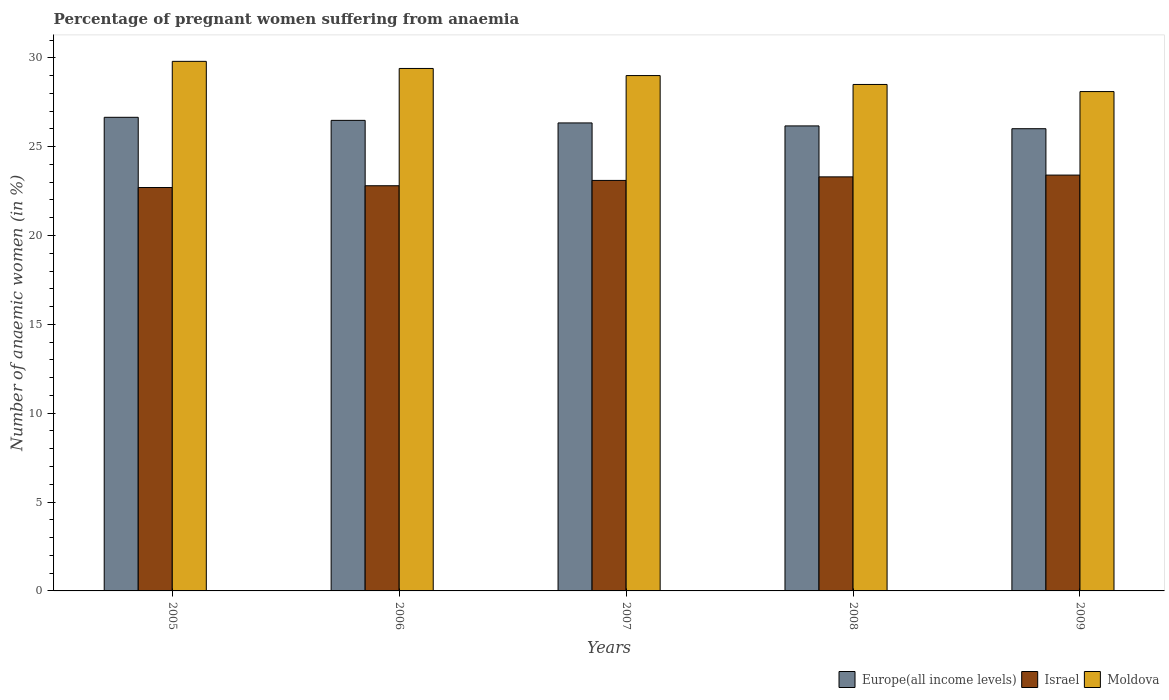How many different coloured bars are there?
Offer a very short reply. 3. How many groups of bars are there?
Offer a very short reply. 5. Are the number of bars per tick equal to the number of legend labels?
Offer a very short reply. Yes. Are the number of bars on each tick of the X-axis equal?
Ensure brevity in your answer.  Yes. How many bars are there on the 2nd tick from the left?
Your answer should be very brief. 3. In how many cases, is the number of bars for a given year not equal to the number of legend labels?
Your answer should be compact. 0. What is the number of anaemic women in Europe(all income levels) in 2007?
Provide a short and direct response. 26.34. Across all years, what is the maximum number of anaemic women in Europe(all income levels)?
Your answer should be compact. 26.65. Across all years, what is the minimum number of anaemic women in Europe(all income levels)?
Give a very brief answer. 26.01. What is the total number of anaemic women in Israel in the graph?
Give a very brief answer. 115.3. What is the difference between the number of anaemic women in Europe(all income levels) in 2008 and that in 2009?
Ensure brevity in your answer.  0.16. What is the difference between the number of anaemic women in Moldova in 2007 and the number of anaemic women in Israel in 2006?
Your answer should be compact. 6.2. What is the average number of anaemic women in Israel per year?
Your answer should be very brief. 23.06. In the year 2007, what is the difference between the number of anaemic women in Europe(all income levels) and number of anaemic women in Israel?
Your answer should be compact. 3.24. What is the ratio of the number of anaemic women in Europe(all income levels) in 2006 to that in 2007?
Your answer should be very brief. 1.01. What is the difference between the highest and the second highest number of anaemic women in Israel?
Your answer should be very brief. 0.1. What is the difference between the highest and the lowest number of anaemic women in Moldova?
Offer a terse response. 1.7. What does the 2nd bar from the right in 2009 represents?
Your answer should be compact. Israel. Is it the case that in every year, the sum of the number of anaemic women in Moldova and number of anaemic women in Europe(all income levels) is greater than the number of anaemic women in Israel?
Give a very brief answer. Yes. Are all the bars in the graph horizontal?
Give a very brief answer. No. What is the difference between two consecutive major ticks on the Y-axis?
Make the answer very short. 5. Does the graph contain grids?
Your response must be concise. No. Where does the legend appear in the graph?
Make the answer very short. Bottom right. What is the title of the graph?
Make the answer very short. Percentage of pregnant women suffering from anaemia. What is the label or title of the Y-axis?
Offer a very short reply. Number of anaemic women (in %). What is the Number of anaemic women (in %) in Europe(all income levels) in 2005?
Your answer should be compact. 26.65. What is the Number of anaemic women (in %) of Israel in 2005?
Provide a succinct answer. 22.7. What is the Number of anaemic women (in %) in Moldova in 2005?
Provide a short and direct response. 29.8. What is the Number of anaemic women (in %) in Europe(all income levels) in 2006?
Make the answer very short. 26.48. What is the Number of anaemic women (in %) of Israel in 2006?
Keep it short and to the point. 22.8. What is the Number of anaemic women (in %) of Moldova in 2006?
Make the answer very short. 29.4. What is the Number of anaemic women (in %) in Europe(all income levels) in 2007?
Your answer should be compact. 26.34. What is the Number of anaemic women (in %) in Israel in 2007?
Your answer should be very brief. 23.1. What is the Number of anaemic women (in %) in Europe(all income levels) in 2008?
Offer a terse response. 26.17. What is the Number of anaemic women (in %) in Israel in 2008?
Keep it short and to the point. 23.3. What is the Number of anaemic women (in %) of Moldova in 2008?
Offer a very short reply. 28.5. What is the Number of anaemic women (in %) in Europe(all income levels) in 2009?
Your response must be concise. 26.01. What is the Number of anaemic women (in %) in Israel in 2009?
Your answer should be very brief. 23.4. What is the Number of anaemic women (in %) in Moldova in 2009?
Your answer should be compact. 28.1. Across all years, what is the maximum Number of anaemic women (in %) in Europe(all income levels)?
Provide a succinct answer. 26.65. Across all years, what is the maximum Number of anaemic women (in %) in Israel?
Offer a very short reply. 23.4. Across all years, what is the maximum Number of anaemic women (in %) of Moldova?
Keep it short and to the point. 29.8. Across all years, what is the minimum Number of anaemic women (in %) of Europe(all income levels)?
Your answer should be compact. 26.01. Across all years, what is the minimum Number of anaemic women (in %) in Israel?
Your answer should be compact. 22.7. Across all years, what is the minimum Number of anaemic women (in %) of Moldova?
Your answer should be compact. 28.1. What is the total Number of anaemic women (in %) in Europe(all income levels) in the graph?
Your answer should be compact. 131.64. What is the total Number of anaemic women (in %) in Israel in the graph?
Your answer should be compact. 115.3. What is the total Number of anaemic women (in %) of Moldova in the graph?
Provide a short and direct response. 144.8. What is the difference between the Number of anaemic women (in %) in Europe(all income levels) in 2005 and that in 2006?
Provide a succinct answer. 0.17. What is the difference between the Number of anaemic women (in %) in Israel in 2005 and that in 2006?
Your answer should be compact. -0.1. What is the difference between the Number of anaemic women (in %) in Europe(all income levels) in 2005 and that in 2007?
Ensure brevity in your answer.  0.32. What is the difference between the Number of anaemic women (in %) in Moldova in 2005 and that in 2007?
Provide a succinct answer. 0.8. What is the difference between the Number of anaemic women (in %) of Europe(all income levels) in 2005 and that in 2008?
Your response must be concise. 0.48. What is the difference between the Number of anaemic women (in %) in Moldova in 2005 and that in 2008?
Make the answer very short. 1.3. What is the difference between the Number of anaemic women (in %) of Europe(all income levels) in 2005 and that in 2009?
Keep it short and to the point. 0.64. What is the difference between the Number of anaemic women (in %) of Moldova in 2005 and that in 2009?
Your response must be concise. 1.7. What is the difference between the Number of anaemic women (in %) of Europe(all income levels) in 2006 and that in 2007?
Give a very brief answer. 0.14. What is the difference between the Number of anaemic women (in %) of Israel in 2006 and that in 2007?
Offer a terse response. -0.3. What is the difference between the Number of anaemic women (in %) of Moldova in 2006 and that in 2007?
Your answer should be compact. 0.4. What is the difference between the Number of anaemic women (in %) in Europe(all income levels) in 2006 and that in 2008?
Your response must be concise. 0.31. What is the difference between the Number of anaemic women (in %) of Israel in 2006 and that in 2008?
Provide a succinct answer. -0.5. What is the difference between the Number of anaemic women (in %) of Moldova in 2006 and that in 2008?
Keep it short and to the point. 0.9. What is the difference between the Number of anaemic women (in %) of Europe(all income levels) in 2006 and that in 2009?
Your response must be concise. 0.47. What is the difference between the Number of anaemic women (in %) of Israel in 2006 and that in 2009?
Offer a very short reply. -0.6. What is the difference between the Number of anaemic women (in %) in Europe(all income levels) in 2007 and that in 2008?
Ensure brevity in your answer.  0.17. What is the difference between the Number of anaemic women (in %) in Moldova in 2007 and that in 2008?
Make the answer very short. 0.5. What is the difference between the Number of anaemic women (in %) in Europe(all income levels) in 2007 and that in 2009?
Give a very brief answer. 0.33. What is the difference between the Number of anaemic women (in %) in Israel in 2007 and that in 2009?
Provide a succinct answer. -0.3. What is the difference between the Number of anaemic women (in %) of Moldova in 2007 and that in 2009?
Your response must be concise. 0.9. What is the difference between the Number of anaemic women (in %) in Europe(all income levels) in 2008 and that in 2009?
Your answer should be compact. 0.16. What is the difference between the Number of anaemic women (in %) in Israel in 2008 and that in 2009?
Offer a terse response. -0.1. What is the difference between the Number of anaemic women (in %) in Moldova in 2008 and that in 2009?
Ensure brevity in your answer.  0.4. What is the difference between the Number of anaemic women (in %) in Europe(all income levels) in 2005 and the Number of anaemic women (in %) in Israel in 2006?
Keep it short and to the point. 3.85. What is the difference between the Number of anaemic women (in %) in Europe(all income levels) in 2005 and the Number of anaemic women (in %) in Moldova in 2006?
Provide a short and direct response. -2.75. What is the difference between the Number of anaemic women (in %) of Europe(all income levels) in 2005 and the Number of anaemic women (in %) of Israel in 2007?
Your answer should be very brief. 3.55. What is the difference between the Number of anaemic women (in %) in Europe(all income levels) in 2005 and the Number of anaemic women (in %) in Moldova in 2007?
Your answer should be compact. -2.35. What is the difference between the Number of anaemic women (in %) of Europe(all income levels) in 2005 and the Number of anaemic women (in %) of Israel in 2008?
Provide a succinct answer. 3.35. What is the difference between the Number of anaemic women (in %) of Europe(all income levels) in 2005 and the Number of anaemic women (in %) of Moldova in 2008?
Provide a succinct answer. -1.85. What is the difference between the Number of anaemic women (in %) of Israel in 2005 and the Number of anaemic women (in %) of Moldova in 2008?
Give a very brief answer. -5.8. What is the difference between the Number of anaemic women (in %) of Europe(all income levels) in 2005 and the Number of anaemic women (in %) of Israel in 2009?
Make the answer very short. 3.25. What is the difference between the Number of anaemic women (in %) in Europe(all income levels) in 2005 and the Number of anaemic women (in %) in Moldova in 2009?
Offer a terse response. -1.45. What is the difference between the Number of anaemic women (in %) of Europe(all income levels) in 2006 and the Number of anaemic women (in %) of Israel in 2007?
Ensure brevity in your answer.  3.38. What is the difference between the Number of anaemic women (in %) of Europe(all income levels) in 2006 and the Number of anaemic women (in %) of Moldova in 2007?
Provide a short and direct response. -2.52. What is the difference between the Number of anaemic women (in %) of Israel in 2006 and the Number of anaemic women (in %) of Moldova in 2007?
Provide a succinct answer. -6.2. What is the difference between the Number of anaemic women (in %) of Europe(all income levels) in 2006 and the Number of anaemic women (in %) of Israel in 2008?
Your response must be concise. 3.18. What is the difference between the Number of anaemic women (in %) of Europe(all income levels) in 2006 and the Number of anaemic women (in %) of Moldova in 2008?
Ensure brevity in your answer.  -2.02. What is the difference between the Number of anaemic women (in %) of Europe(all income levels) in 2006 and the Number of anaemic women (in %) of Israel in 2009?
Ensure brevity in your answer.  3.08. What is the difference between the Number of anaemic women (in %) in Europe(all income levels) in 2006 and the Number of anaemic women (in %) in Moldova in 2009?
Your answer should be compact. -1.62. What is the difference between the Number of anaemic women (in %) of Europe(all income levels) in 2007 and the Number of anaemic women (in %) of Israel in 2008?
Offer a very short reply. 3.04. What is the difference between the Number of anaemic women (in %) of Europe(all income levels) in 2007 and the Number of anaemic women (in %) of Moldova in 2008?
Your answer should be compact. -2.16. What is the difference between the Number of anaemic women (in %) of Europe(all income levels) in 2007 and the Number of anaemic women (in %) of Israel in 2009?
Your answer should be compact. 2.94. What is the difference between the Number of anaemic women (in %) in Europe(all income levels) in 2007 and the Number of anaemic women (in %) in Moldova in 2009?
Provide a short and direct response. -1.76. What is the difference between the Number of anaemic women (in %) in Israel in 2007 and the Number of anaemic women (in %) in Moldova in 2009?
Give a very brief answer. -5. What is the difference between the Number of anaemic women (in %) in Europe(all income levels) in 2008 and the Number of anaemic women (in %) in Israel in 2009?
Give a very brief answer. 2.77. What is the difference between the Number of anaemic women (in %) of Europe(all income levels) in 2008 and the Number of anaemic women (in %) of Moldova in 2009?
Your answer should be compact. -1.93. What is the average Number of anaemic women (in %) of Europe(all income levels) per year?
Your answer should be very brief. 26.33. What is the average Number of anaemic women (in %) in Israel per year?
Your response must be concise. 23.06. What is the average Number of anaemic women (in %) of Moldova per year?
Your answer should be very brief. 28.96. In the year 2005, what is the difference between the Number of anaemic women (in %) of Europe(all income levels) and Number of anaemic women (in %) of Israel?
Give a very brief answer. 3.95. In the year 2005, what is the difference between the Number of anaemic women (in %) in Europe(all income levels) and Number of anaemic women (in %) in Moldova?
Ensure brevity in your answer.  -3.15. In the year 2006, what is the difference between the Number of anaemic women (in %) of Europe(all income levels) and Number of anaemic women (in %) of Israel?
Provide a short and direct response. 3.68. In the year 2006, what is the difference between the Number of anaemic women (in %) in Europe(all income levels) and Number of anaemic women (in %) in Moldova?
Your answer should be compact. -2.92. In the year 2007, what is the difference between the Number of anaemic women (in %) in Europe(all income levels) and Number of anaemic women (in %) in Israel?
Offer a terse response. 3.24. In the year 2007, what is the difference between the Number of anaemic women (in %) in Europe(all income levels) and Number of anaemic women (in %) in Moldova?
Keep it short and to the point. -2.66. In the year 2007, what is the difference between the Number of anaemic women (in %) of Israel and Number of anaemic women (in %) of Moldova?
Ensure brevity in your answer.  -5.9. In the year 2008, what is the difference between the Number of anaemic women (in %) of Europe(all income levels) and Number of anaemic women (in %) of Israel?
Provide a succinct answer. 2.87. In the year 2008, what is the difference between the Number of anaemic women (in %) in Europe(all income levels) and Number of anaemic women (in %) in Moldova?
Make the answer very short. -2.33. In the year 2009, what is the difference between the Number of anaemic women (in %) in Europe(all income levels) and Number of anaemic women (in %) in Israel?
Offer a terse response. 2.61. In the year 2009, what is the difference between the Number of anaemic women (in %) of Europe(all income levels) and Number of anaemic women (in %) of Moldova?
Your answer should be very brief. -2.09. In the year 2009, what is the difference between the Number of anaemic women (in %) in Israel and Number of anaemic women (in %) in Moldova?
Keep it short and to the point. -4.7. What is the ratio of the Number of anaemic women (in %) of Europe(all income levels) in 2005 to that in 2006?
Provide a succinct answer. 1.01. What is the ratio of the Number of anaemic women (in %) of Israel in 2005 to that in 2006?
Give a very brief answer. 1. What is the ratio of the Number of anaemic women (in %) in Moldova in 2005 to that in 2006?
Your answer should be very brief. 1.01. What is the ratio of the Number of anaemic women (in %) of Israel in 2005 to that in 2007?
Provide a short and direct response. 0.98. What is the ratio of the Number of anaemic women (in %) in Moldova in 2005 to that in 2007?
Provide a short and direct response. 1.03. What is the ratio of the Number of anaemic women (in %) in Europe(all income levels) in 2005 to that in 2008?
Your answer should be compact. 1.02. What is the ratio of the Number of anaemic women (in %) of Israel in 2005 to that in 2008?
Offer a terse response. 0.97. What is the ratio of the Number of anaemic women (in %) of Moldova in 2005 to that in 2008?
Your answer should be compact. 1.05. What is the ratio of the Number of anaemic women (in %) of Europe(all income levels) in 2005 to that in 2009?
Ensure brevity in your answer.  1.02. What is the ratio of the Number of anaemic women (in %) of Israel in 2005 to that in 2009?
Make the answer very short. 0.97. What is the ratio of the Number of anaemic women (in %) of Moldova in 2005 to that in 2009?
Give a very brief answer. 1.06. What is the ratio of the Number of anaemic women (in %) of Israel in 2006 to that in 2007?
Your answer should be very brief. 0.99. What is the ratio of the Number of anaemic women (in %) of Moldova in 2006 to that in 2007?
Your answer should be very brief. 1.01. What is the ratio of the Number of anaemic women (in %) in Europe(all income levels) in 2006 to that in 2008?
Offer a terse response. 1.01. What is the ratio of the Number of anaemic women (in %) of Israel in 2006 to that in 2008?
Keep it short and to the point. 0.98. What is the ratio of the Number of anaemic women (in %) of Moldova in 2006 to that in 2008?
Your answer should be compact. 1.03. What is the ratio of the Number of anaemic women (in %) of Europe(all income levels) in 2006 to that in 2009?
Your answer should be compact. 1.02. What is the ratio of the Number of anaemic women (in %) in Israel in 2006 to that in 2009?
Give a very brief answer. 0.97. What is the ratio of the Number of anaemic women (in %) in Moldova in 2006 to that in 2009?
Provide a succinct answer. 1.05. What is the ratio of the Number of anaemic women (in %) of Europe(all income levels) in 2007 to that in 2008?
Your response must be concise. 1.01. What is the ratio of the Number of anaemic women (in %) in Israel in 2007 to that in 2008?
Offer a very short reply. 0.99. What is the ratio of the Number of anaemic women (in %) in Moldova in 2007 to that in 2008?
Your response must be concise. 1.02. What is the ratio of the Number of anaemic women (in %) in Europe(all income levels) in 2007 to that in 2009?
Make the answer very short. 1.01. What is the ratio of the Number of anaemic women (in %) of Israel in 2007 to that in 2009?
Keep it short and to the point. 0.99. What is the ratio of the Number of anaemic women (in %) in Moldova in 2007 to that in 2009?
Provide a short and direct response. 1.03. What is the ratio of the Number of anaemic women (in %) of Europe(all income levels) in 2008 to that in 2009?
Offer a very short reply. 1.01. What is the ratio of the Number of anaemic women (in %) in Moldova in 2008 to that in 2009?
Your response must be concise. 1.01. What is the difference between the highest and the second highest Number of anaemic women (in %) in Europe(all income levels)?
Give a very brief answer. 0.17. What is the difference between the highest and the second highest Number of anaemic women (in %) in Israel?
Your answer should be compact. 0.1. What is the difference between the highest and the second highest Number of anaemic women (in %) in Moldova?
Provide a short and direct response. 0.4. What is the difference between the highest and the lowest Number of anaemic women (in %) in Europe(all income levels)?
Keep it short and to the point. 0.64. What is the difference between the highest and the lowest Number of anaemic women (in %) in Israel?
Provide a short and direct response. 0.7. 